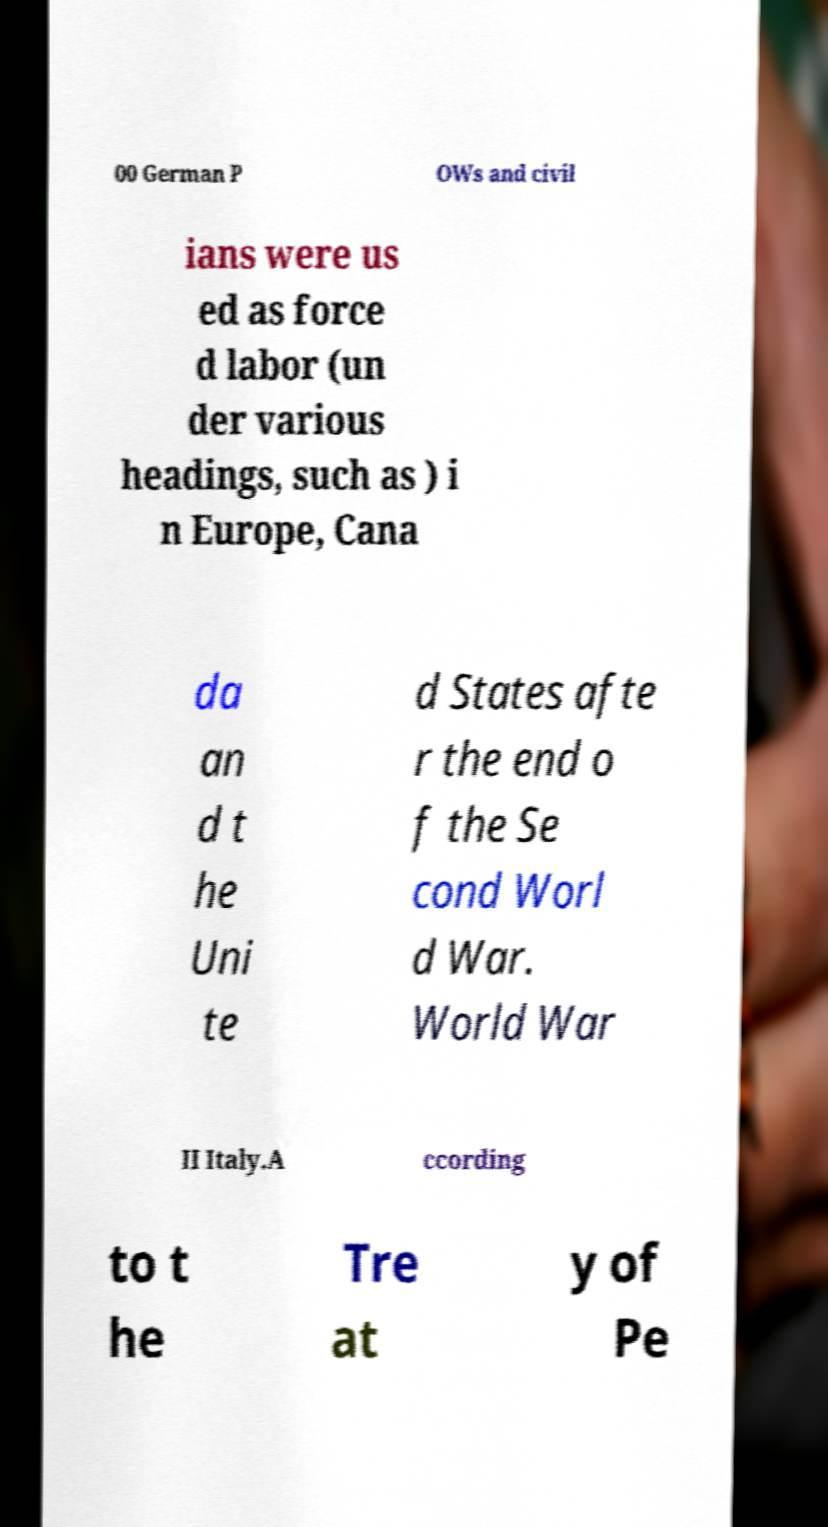Please identify and transcribe the text found in this image. 00 German P OWs and civil ians were us ed as force d labor (un der various headings, such as ) i n Europe, Cana da an d t he Uni te d States afte r the end o f the Se cond Worl d War. World War II Italy.A ccording to t he Tre at y of Pe 